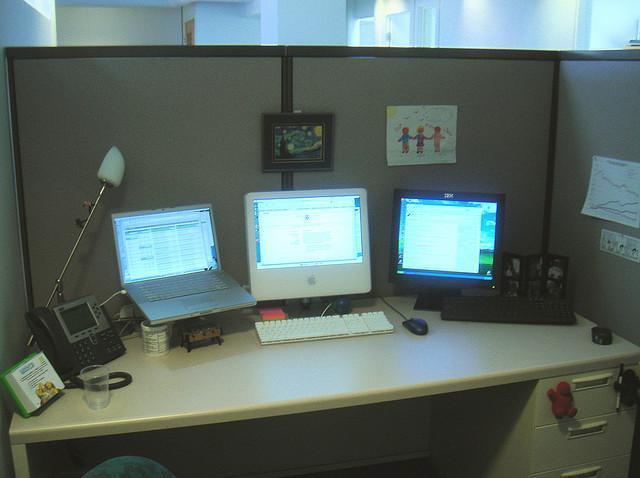How many comps are there?
Give a very brief answer. 3. How many pieces of paper are hanging in the cubicle?
Give a very brief answer. 2. How many display screens are on?
Give a very brief answer. 3. How many tvs are in the picture?
Give a very brief answer. 2. How many keyboards are there?
Give a very brief answer. 2. 